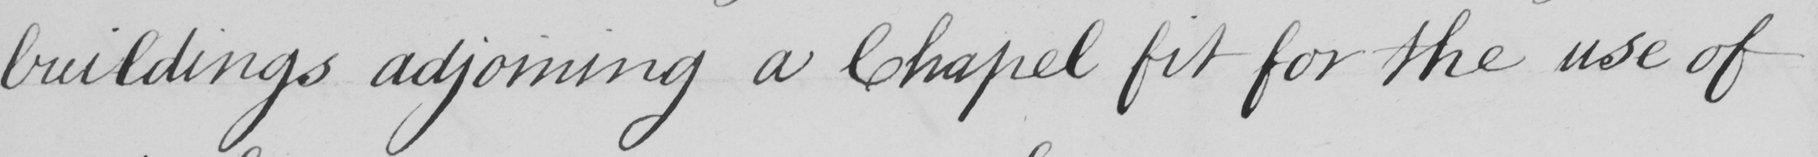What text is written in this handwritten line? buildings adjoining a Chapel fit for the use of 